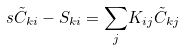Convert formula to latex. <formula><loc_0><loc_0><loc_500><loc_500>s \tilde { C } _ { k i } - S _ { k i } = { \sum _ { j } } K _ { i j } \tilde { C } _ { k j }</formula> 